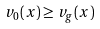<formula> <loc_0><loc_0><loc_500><loc_500>v _ { 0 } ( x ) \geq v _ { g } ( x )</formula> 